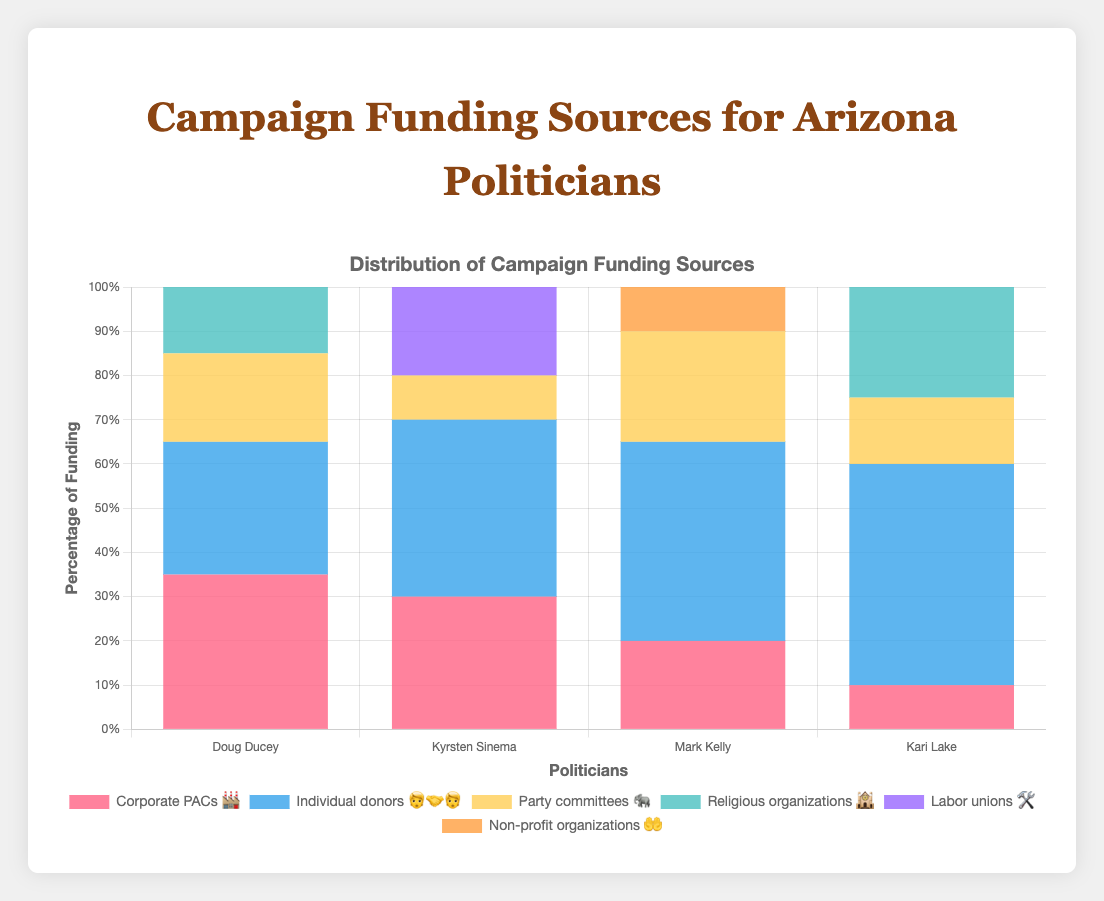What is the most significant funding source for Kari Lake? The figure shows Kari Lake’s campaign funding sources, with the percentage of each source. The most significant funding source for Kari Lake is Individual Donors 🧑‍🤝‍🧑 at 50%.
Answer: Individual Donors 🧑‍🤝‍🧑 Which politician receives the highest percentage of funding from Religious Organizations 🕍? By scanning the percentages given in the chart for funding from Religious Organizations 🕍, we see that Kari Lake receives 25% of her funding from this source, which is higher than Doug Ducey's 15%.
Answer: Kari Lake What is the combined percentage of funding from Corporate PACs 🏭 and Individual Donors 🧑‍🤝‍🧑 for Doug Ducey? Doug Ducey's funding from Corporate PACs 🏭 is 35% and from Individual Donors 🧑‍🤝‍🧑 is 30%. Adding them together, 35% + 30% = 65%.
Answer: 65% Who has a higher percentage of funding from Individual Donors 🧑‍🤝‍🧑, Kyrsten Sinema or Mark Kelly? The figure shows that Kyrsten Sinema receives 40% from Individual Donors 🧑‍🤝‍🧑 while Mark Kelly receives 45%. Therefore, Mark Kelly has a higher percentage from this source.
Answer: Mark Kelly Among all politicians, which type of funding source is most common? By examining the various percentages, Individual Donors 🧑‍🤝‍🧑 appears as a funding source for all four politicians and has high percentages across the board, making it the most common type.
Answer: Individual Donors 🧑‍🤝‍🧑 What is the percentage difference in Religious Organizations 🕍 funding between Doug Ducey and Kari Lake? Doug Ducey gets 15% from Religious Organizations 🕍, whereas Kari Lake gets 25%. The difference is 25% - 15% = 10%.
Answer: 10% Whose campaign has the least diversity in funding sources, and why? Kari Lake's campaign has the least diversity in funding, as Individual Donors 🧑‍🤝‍🧑 make up 50% of her total funding, overshadowing other sources.
Answer: Kari Lake Which politician has the smallest funding from Party Committees 🐘? The figure shows Kyrsten Sinema with 10% from Party Committees 🐘, which is the smallest percentage among all four politicians.
Answer: Kyrsten Sinema What sum represents all percentages for Mark Kelly? Adding up all percentages for Mark Kelly: 45% (Individual Donors 🧑‍🤝‍🧑) + 25% (Party Committees 🐘) + 20% (Corporate PACs 🏭) + 10% (Non-profit Organizations 🤲) equals 100%.
Answer: 100% In terms of Corporate PACs 🏭, who receives a higher percentage, Doug Ducey or Kyrsten Sinema? Doug Ducey receives 35% from Corporate PACs 🏭 while Kyrsten Sinema receives 30%. Therefore, Doug Ducey receives a higher percentage from Corporate PACs 🏭.
Answer: Doug Ducey 